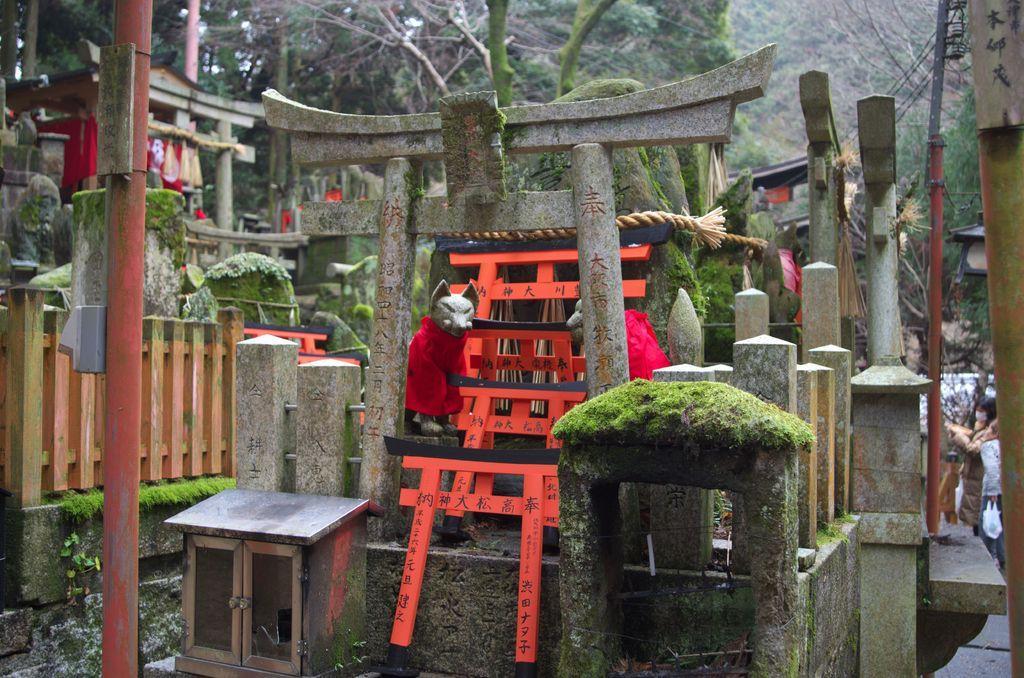Please provide a concise description of this image. In this image there is a chinese sculpture in the middle there is a rat toy, below that there is a box, on the left side there is a railing and pole, on the right side there are two persons standing and there is pole in the background there trees. 